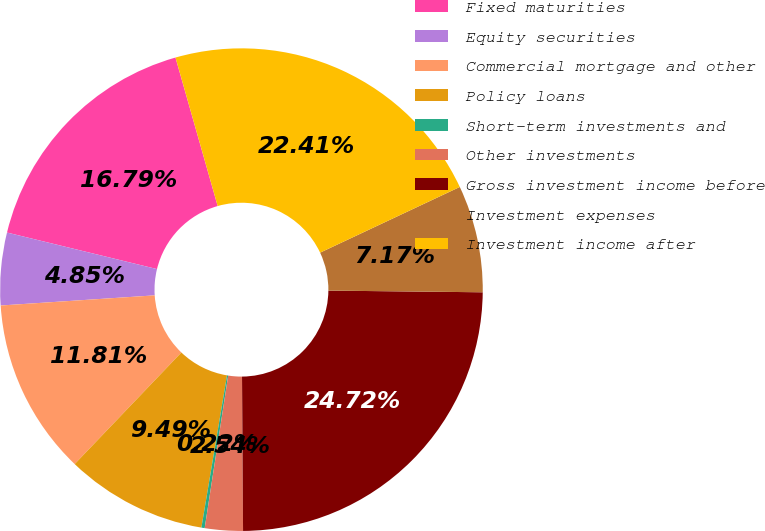Convert chart. <chart><loc_0><loc_0><loc_500><loc_500><pie_chart><fcel>Fixed maturities<fcel>Equity securities<fcel>Commercial mortgage and other<fcel>Policy loans<fcel>Short-term investments and<fcel>Other investments<fcel>Gross investment income before<fcel>Investment expenses<fcel>Investment income after<nl><fcel>16.79%<fcel>4.85%<fcel>11.81%<fcel>9.49%<fcel>0.22%<fcel>2.54%<fcel>24.72%<fcel>7.17%<fcel>22.41%<nl></chart> 